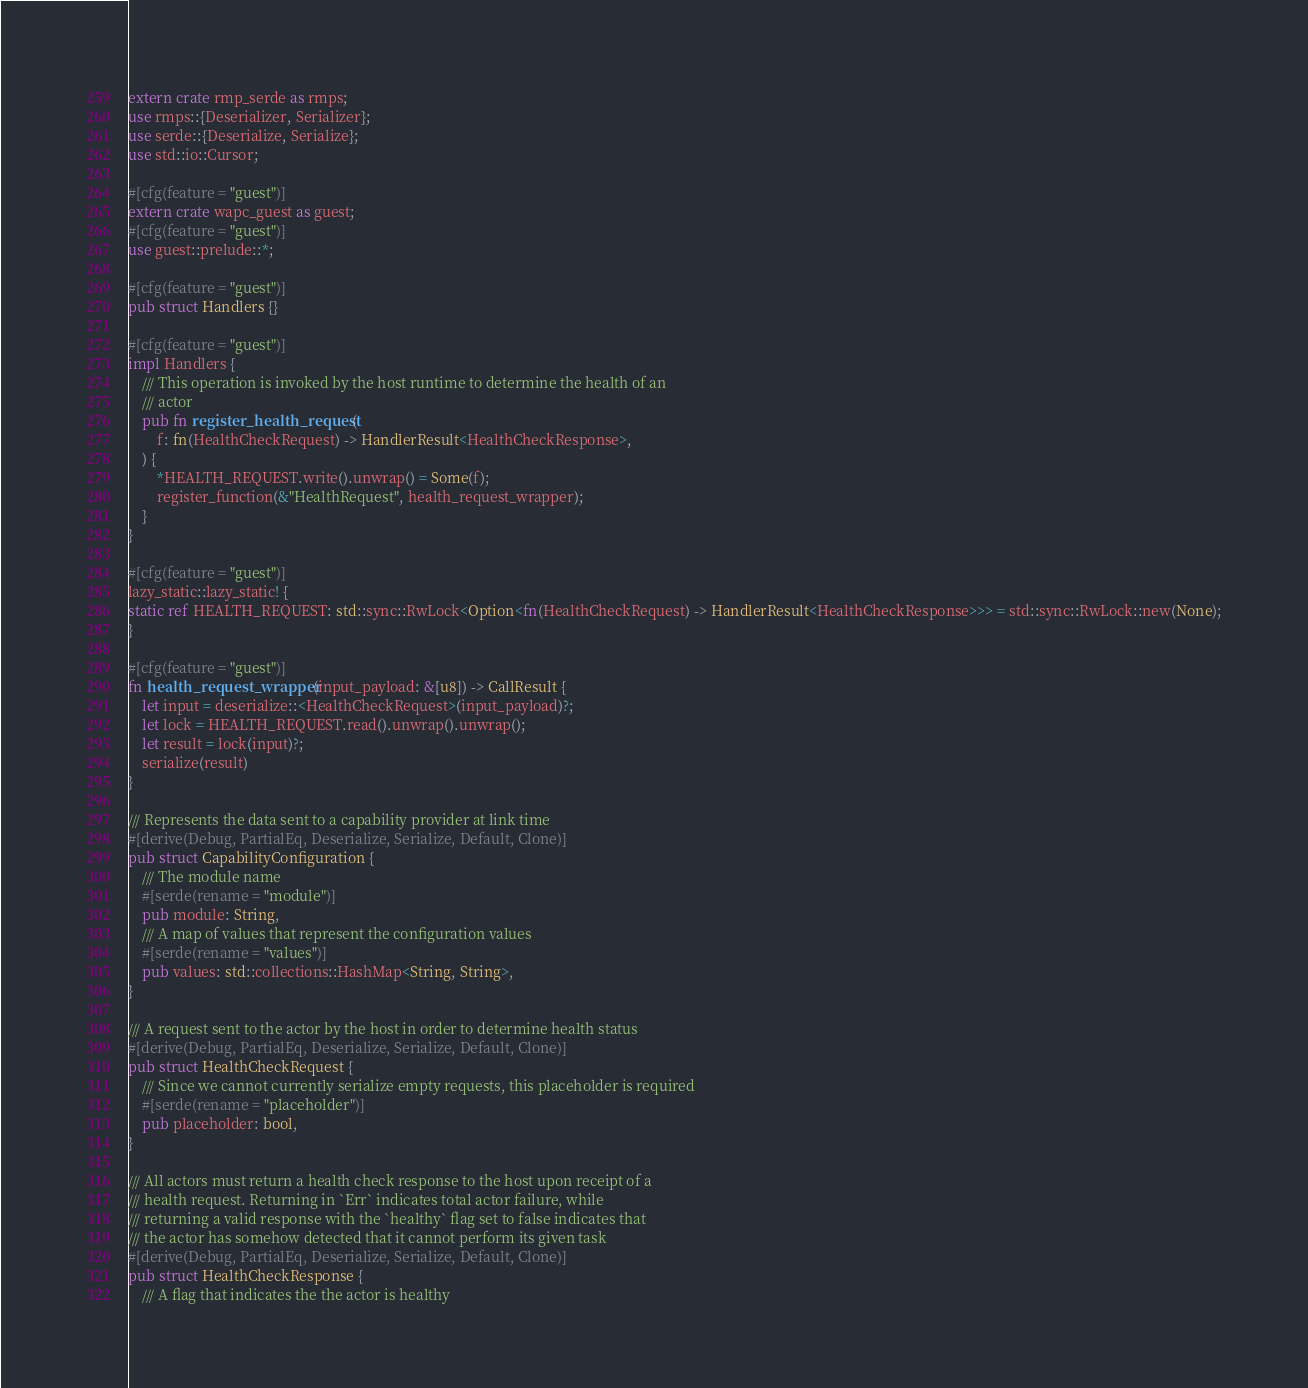<code> <loc_0><loc_0><loc_500><loc_500><_Rust_>extern crate rmp_serde as rmps;
use rmps::{Deserializer, Serializer};
use serde::{Deserialize, Serialize};
use std::io::Cursor;

#[cfg(feature = "guest")]
extern crate wapc_guest as guest;
#[cfg(feature = "guest")]
use guest::prelude::*;

#[cfg(feature = "guest")]
pub struct Handlers {}

#[cfg(feature = "guest")]
impl Handlers {
    /// This operation is invoked by the host runtime to determine the health of an
    /// actor
    pub fn register_health_request(
        f: fn(HealthCheckRequest) -> HandlerResult<HealthCheckResponse>,
    ) {
        *HEALTH_REQUEST.write().unwrap() = Some(f);
        register_function(&"HealthRequest", health_request_wrapper);
    }
}

#[cfg(feature = "guest")]
lazy_static::lazy_static! {
static ref HEALTH_REQUEST: std::sync::RwLock<Option<fn(HealthCheckRequest) -> HandlerResult<HealthCheckResponse>>> = std::sync::RwLock::new(None);
}

#[cfg(feature = "guest")]
fn health_request_wrapper(input_payload: &[u8]) -> CallResult {
    let input = deserialize::<HealthCheckRequest>(input_payload)?;
    let lock = HEALTH_REQUEST.read().unwrap().unwrap();
    let result = lock(input)?;
    serialize(result)
}

/// Represents the data sent to a capability provider at link time
#[derive(Debug, PartialEq, Deserialize, Serialize, Default, Clone)]
pub struct CapabilityConfiguration {
    /// The module name
    #[serde(rename = "module")]
    pub module: String,
    /// A map of values that represent the configuration values
    #[serde(rename = "values")]
    pub values: std::collections::HashMap<String, String>,
}

/// A request sent to the actor by the host in order to determine health status
#[derive(Debug, PartialEq, Deserialize, Serialize, Default, Clone)]
pub struct HealthCheckRequest {
    /// Since we cannot currently serialize empty requests, this placeholder is required
    #[serde(rename = "placeholder")]
    pub placeholder: bool,
}

/// All actors must return a health check response to the host upon receipt of a
/// health request. Returning in `Err` indicates total actor failure, while
/// returning a valid response with the `healthy` flag set to false indicates that
/// the actor has somehow detected that it cannot perform its given task
#[derive(Debug, PartialEq, Deserialize, Serialize, Default, Clone)]
pub struct HealthCheckResponse {
    /// A flag that indicates the the actor is healthy</code> 